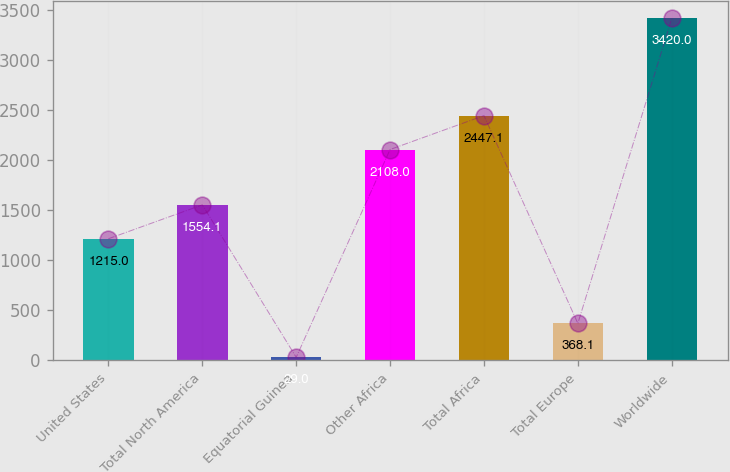Convert chart. <chart><loc_0><loc_0><loc_500><loc_500><bar_chart><fcel>United States<fcel>Total North America<fcel>Equatorial Guinea<fcel>Other Africa<fcel>Total Africa<fcel>Total Europe<fcel>Worldwide<nl><fcel>1215<fcel>1554.1<fcel>29<fcel>2108<fcel>2447.1<fcel>368.1<fcel>3420<nl></chart> 